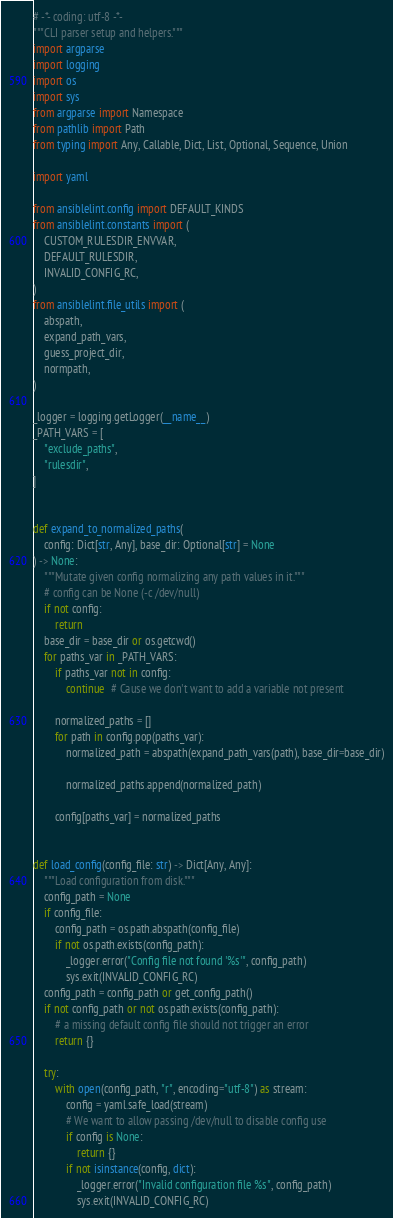Convert code to text. <code><loc_0><loc_0><loc_500><loc_500><_Python_># -*- coding: utf-8 -*-
"""CLI parser setup and helpers."""
import argparse
import logging
import os
import sys
from argparse import Namespace
from pathlib import Path
from typing import Any, Callable, Dict, List, Optional, Sequence, Union

import yaml

from ansiblelint.config import DEFAULT_KINDS
from ansiblelint.constants import (
    CUSTOM_RULESDIR_ENVVAR,
    DEFAULT_RULESDIR,
    INVALID_CONFIG_RC,
)
from ansiblelint.file_utils import (
    abspath,
    expand_path_vars,
    guess_project_dir,
    normpath,
)

_logger = logging.getLogger(__name__)
_PATH_VARS = [
    "exclude_paths",
    "rulesdir",
]


def expand_to_normalized_paths(
    config: Dict[str, Any], base_dir: Optional[str] = None
) -> None:
    """Mutate given config normalizing any path values in it."""
    # config can be None (-c /dev/null)
    if not config:
        return
    base_dir = base_dir or os.getcwd()
    for paths_var in _PATH_VARS:
        if paths_var not in config:
            continue  # Cause we don't want to add a variable not present

        normalized_paths = []
        for path in config.pop(paths_var):
            normalized_path = abspath(expand_path_vars(path), base_dir=base_dir)

            normalized_paths.append(normalized_path)

        config[paths_var] = normalized_paths


def load_config(config_file: str) -> Dict[Any, Any]:
    """Load configuration from disk."""
    config_path = None
    if config_file:
        config_path = os.path.abspath(config_file)
        if not os.path.exists(config_path):
            _logger.error("Config file not found '%s'", config_path)
            sys.exit(INVALID_CONFIG_RC)
    config_path = config_path or get_config_path()
    if not config_path or not os.path.exists(config_path):
        # a missing default config file should not trigger an error
        return {}

    try:
        with open(config_path, "r", encoding="utf-8") as stream:
            config = yaml.safe_load(stream)
            # We want to allow passing /dev/null to disable config use
            if config is None:
                return {}
            if not isinstance(config, dict):
                _logger.error("Invalid configuration file %s", config_path)
                sys.exit(INVALID_CONFIG_RC)</code> 